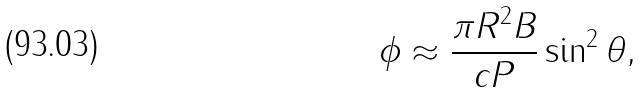Convert formula to latex. <formula><loc_0><loc_0><loc_500><loc_500>\phi \approx \frac { \pi R ^ { 2 } B } { c P } \sin ^ { 2 } \theta ,</formula> 